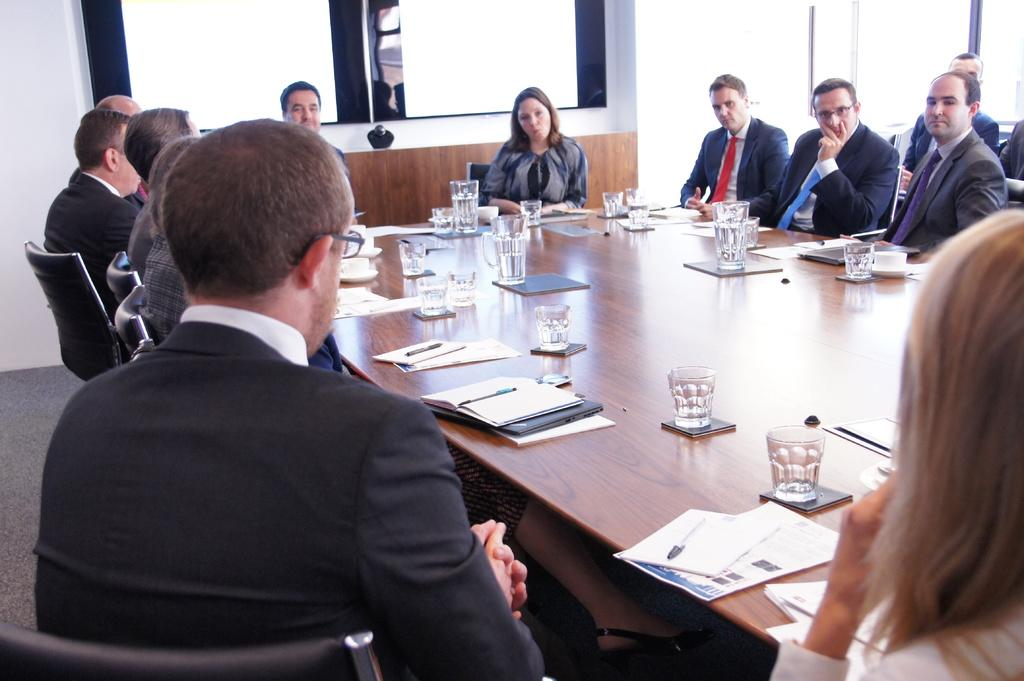What are the people in the room doing? The people in the room are sitting in chairs. What is in front of the people? There is a table in front of the people. What can be found on the table? There are different items on the table. Are there any bats flying around in the room? There is no mention of bats in the image, so we cannot determine if there are any bats present. 